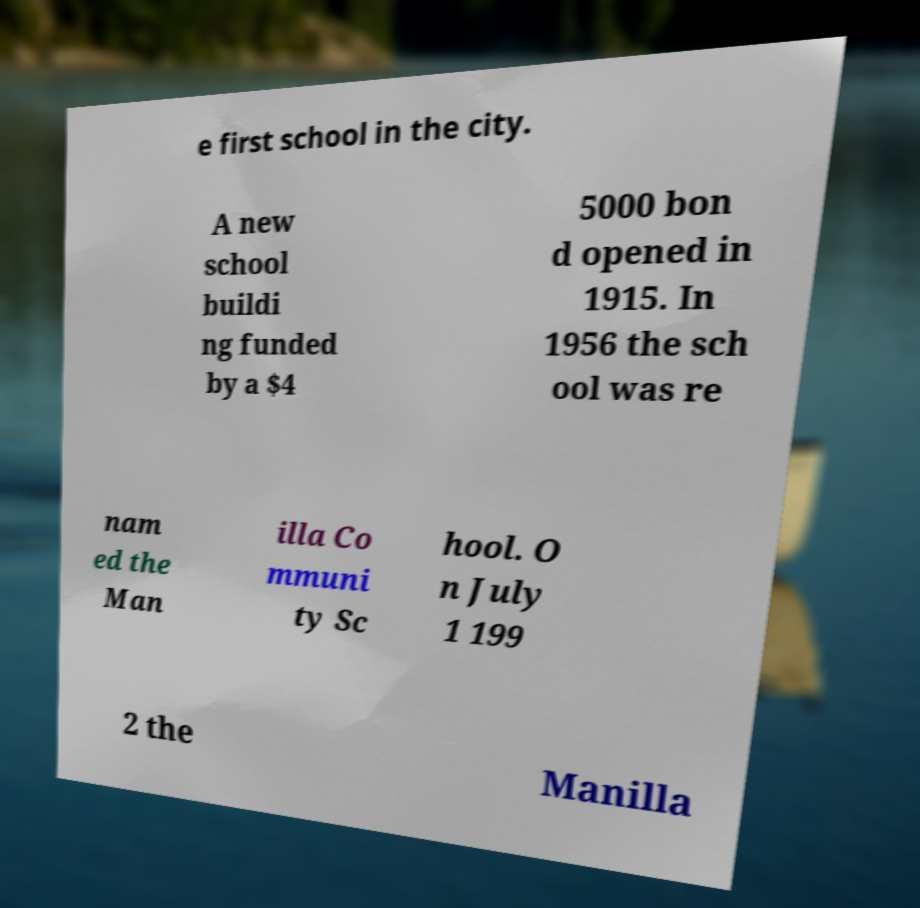For documentation purposes, I need the text within this image transcribed. Could you provide that? e first school in the city. A new school buildi ng funded by a $4 5000 bon d opened in 1915. In 1956 the sch ool was re nam ed the Man illa Co mmuni ty Sc hool. O n July 1 199 2 the Manilla 